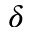Convert formula to latex. <formula><loc_0><loc_0><loc_500><loc_500>\delta</formula> 